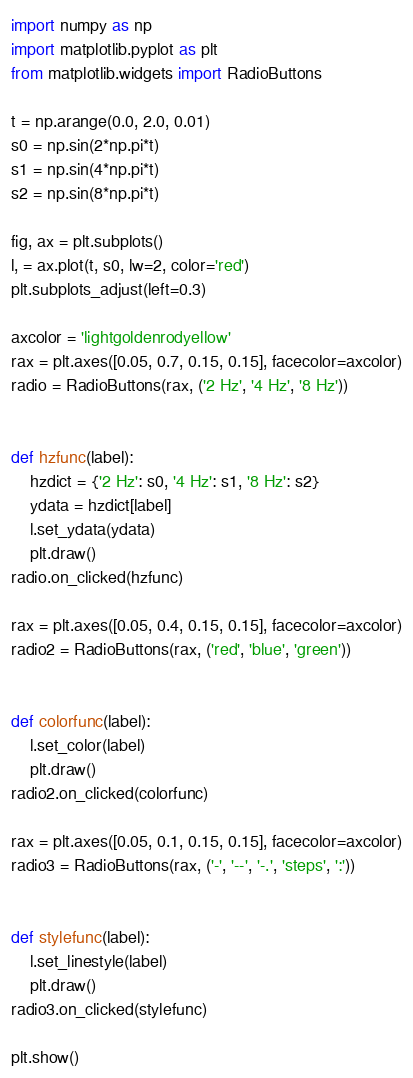<code> <loc_0><loc_0><loc_500><loc_500><_Python_>import numpy as np
import matplotlib.pyplot as plt
from matplotlib.widgets import RadioButtons

t = np.arange(0.0, 2.0, 0.01)
s0 = np.sin(2*np.pi*t)
s1 = np.sin(4*np.pi*t)
s2 = np.sin(8*np.pi*t)

fig, ax = plt.subplots()
l, = ax.plot(t, s0, lw=2, color='red')
plt.subplots_adjust(left=0.3)

axcolor = 'lightgoldenrodyellow'
rax = plt.axes([0.05, 0.7, 0.15, 0.15], facecolor=axcolor)
radio = RadioButtons(rax, ('2 Hz', '4 Hz', '8 Hz'))


def hzfunc(label):
    hzdict = {'2 Hz': s0, '4 Hz': s1, '8 Hz': s2}
    ydata = hzdict[label]
    l.set_ydata(ydata)
    plt.draw()
radio.on_clicked(hzfunc)

rax = plt.axes([0.05, 0.4, 0.15, 0.15], facecolor=axcolor)
radio2 = RadioButtons(rax, ('red', 'blue', 'green'))


def colorfunc(label):
    l.set_color(label)
    plt.draw()
radio2.on_clicked(colorfunc)

rax = plt.axes([0.05, 0.1, 0.15, 0.15], facecolor=axcolor)
radio3 = RadioButtons(rax, ('-', '--', '-.', 'steps', ':'))


def stylefunc(label):
    l.set_linestyle(label)
    plt.draw()
radio3.on_clicked(stylefunc)

plt.show()</code> 